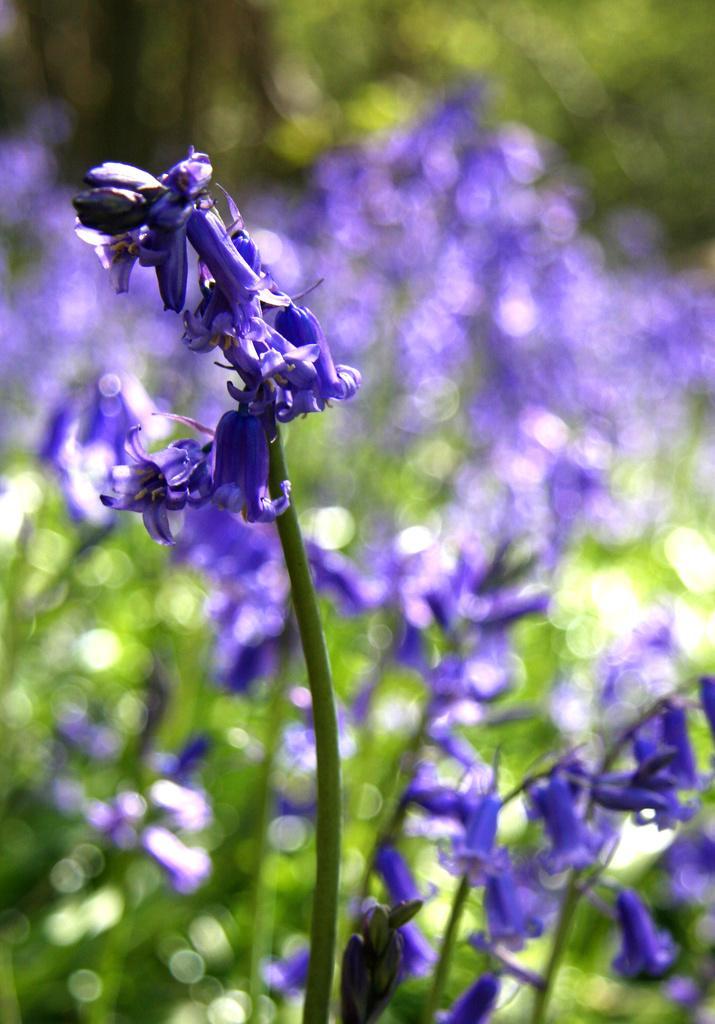How would you summarize this image in a sentence or two? In the picture we can see plants with flowers which are violet in color and behind it, we can see some plants and flowers which are not clearly visible. 